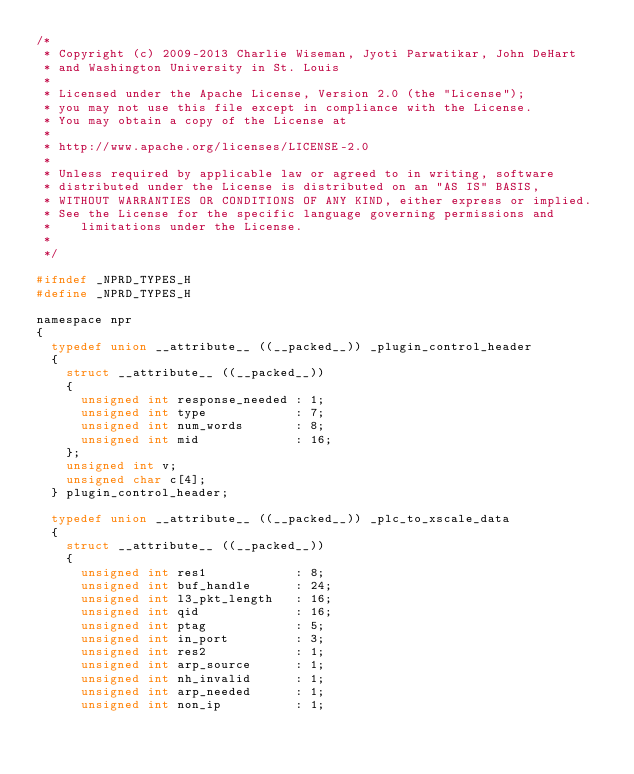Convert code to text. <code><loc_0><loc_0><loc_500><loc_500><_C_>/*
 * Copyright (c) 2009-2013 Charlie Wiseman, Jyoti Parwatikar, John DeHart 
 * and Washington University in St. Louis
 *
 * Licensed under the Apache License, Version 2.0 (the "License");
 * you may not use this file except in compliance with the License.
 * You may obtain a copy of the License at
 *
 * http://www.apache.org/licenses/LICENSE-2.0
 *
 * Unless required by applicable law or agreed to in writing, software
 * distributed under the License is distributed on an "AS IS" BASIS,
 * WITHOUT WARRANTIES OR CONDITIONS OF ANY KIND, either express or implied.
 * See the License for the specific language governing permissions and
 *    limitations under the License.
 *
 */

#ifndef _NPRD_TYPES_H
#define _NPRD_TYPES_H

namespace npr 
{
  typedef union __attribute__ ((__packed__)) _plugin_control_header
  {
    struct __attribute__ ((__packed__))
    {
      unsigned int response_needed : 1;
      unsigned int type            : 7;
      unsigned int num_words       : 8;
      unsigned int mid             : 16;
    };
    unsigned int v;
    unsigned char c[4];
  } plugin_control_header;

  typedef union __attribute__ ((__packed__)) _plc_to_xscale_data
  {
    struct __attribute__ ((__packed__))
    {
      unsigned int res1            : 8;
      unsigned int buf_handle      : 24;
      unsigned int l3_pkt_length   : 16;
      unsigned int qid             : 16;
      unsigned int ptag            : 5;
      unsigned int in_port         : 3;
      unsigned int res2            : 1;
      unsigned int arp_source      : 1;
      unsigned int nh_invalid      : 1;
      unsigned int arp_needed      : 1;
      unsigned int non_ip          : 1;</code> 